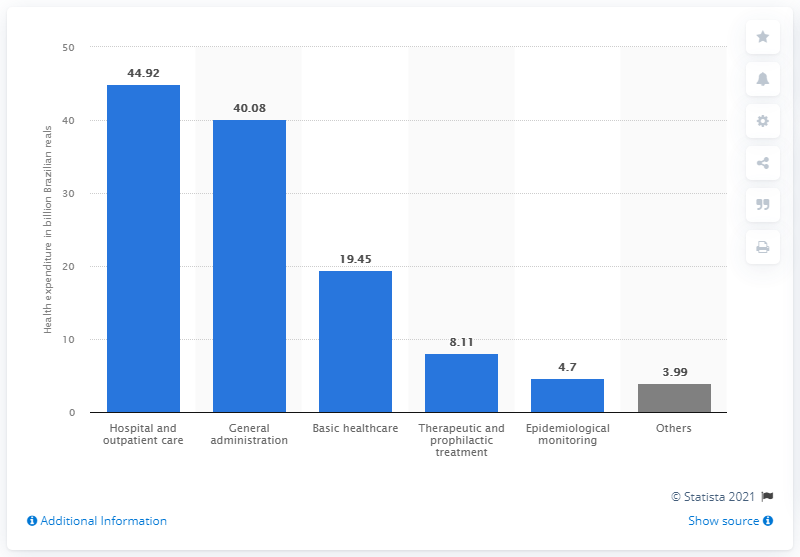Mention a couple of crucial points in this snapshot. As of October 2020, the Brazilian government had spent approximately 4.7 real on health expenditures. 